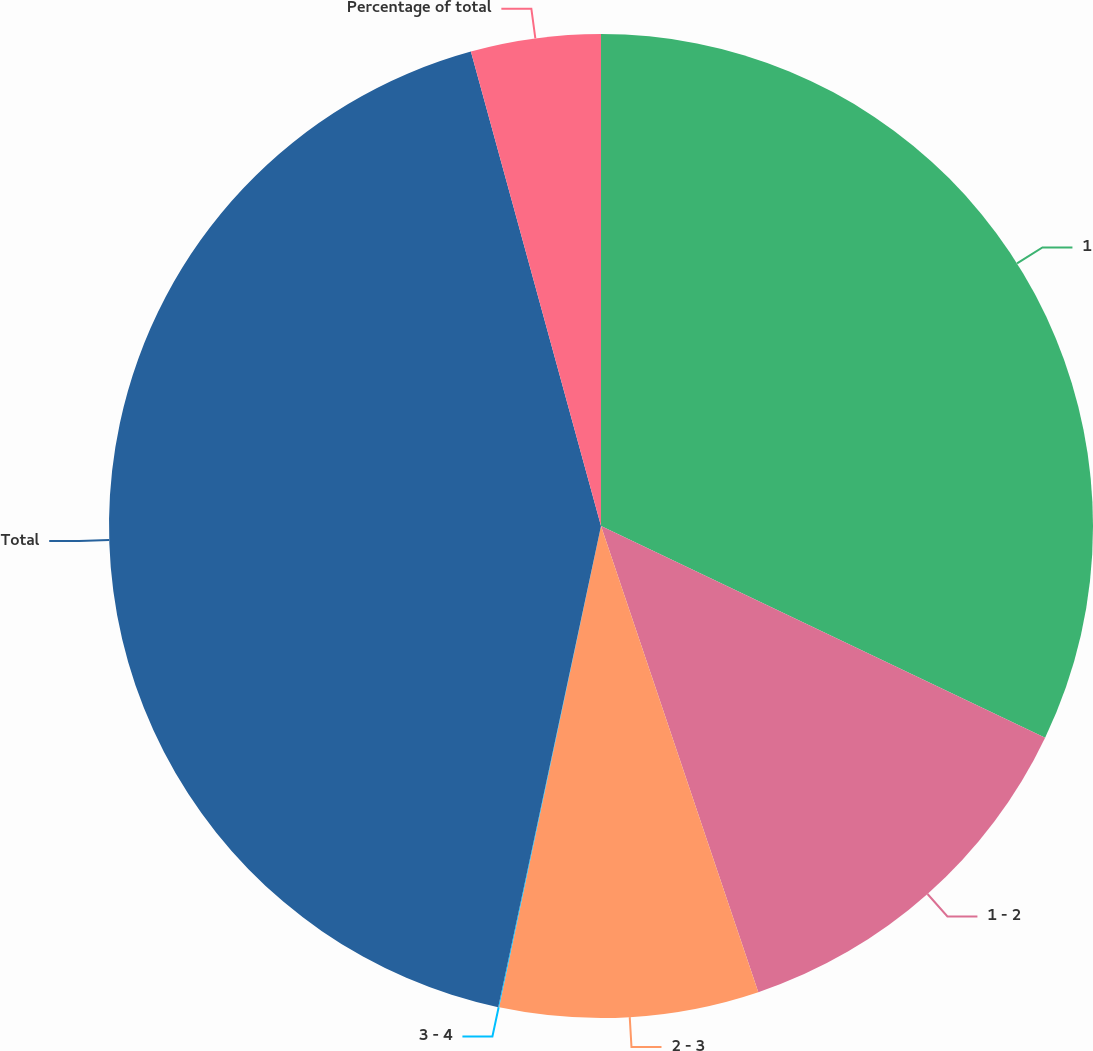Convert chart to OTSL. <chart><loc_0><loc_0><loc_500><loc_500><pie_chart><fcel>1<fcel>1 - 2<fcel>2 - 3<fcel>3 - 4<fcel>Total<fcel>Percentage of total<nl><fcel>32.08%<fcel>12.74%<fcel>8.5%<fcel>0.03%<fcel>42.39%<fcel>4.26%<nl></chart> 